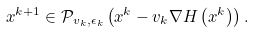<formula> <loc_0><loc_0><loc_500><loc_500>x ^ { k + 1 } \in \mathcal { P } _ { v _ { k } , \epsilon _ { k } } \left ( x ^ { k } - v _ { k } \nabla H \left ( x ^ { k } \right ) \right ) .</formula> 